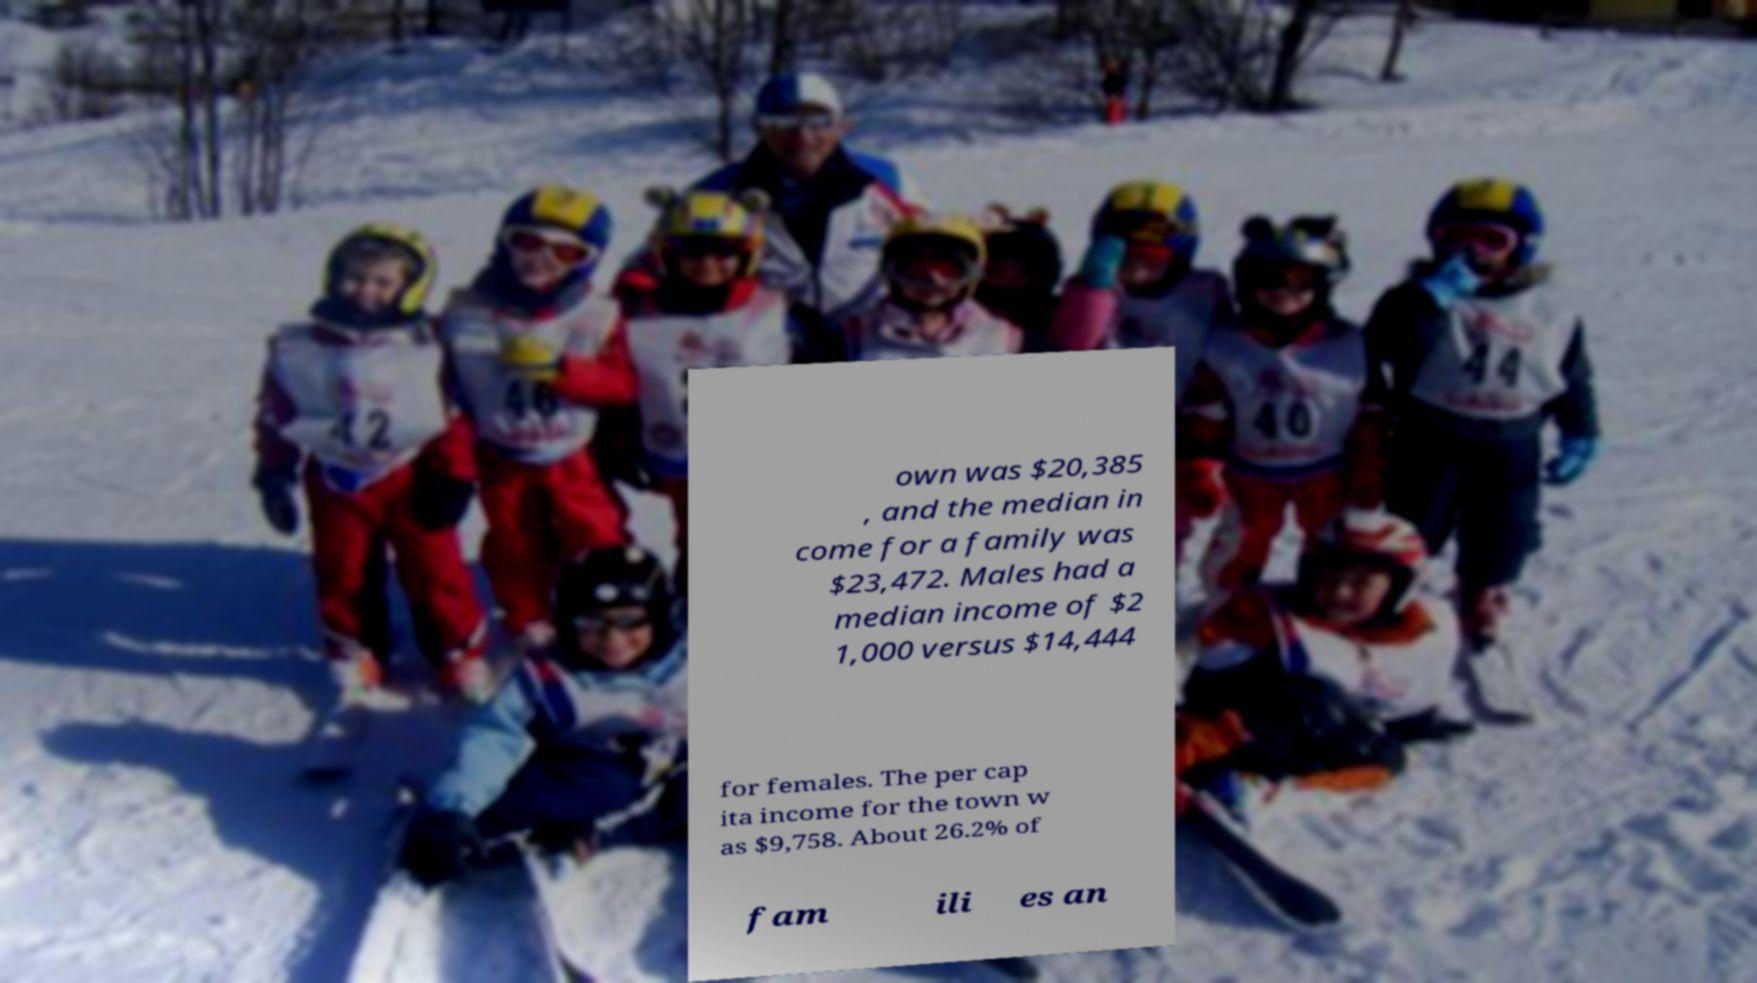There's text embedded in this image that I need extracted. Can you transcribe it verbatim? own was $20,385 , and the median in come for a family was $23,472. Males had a median income of $2 1,000 versus $14,444 for females. The per cap ita income for the town w as $9,758. About 26.2% of fam ili es an 